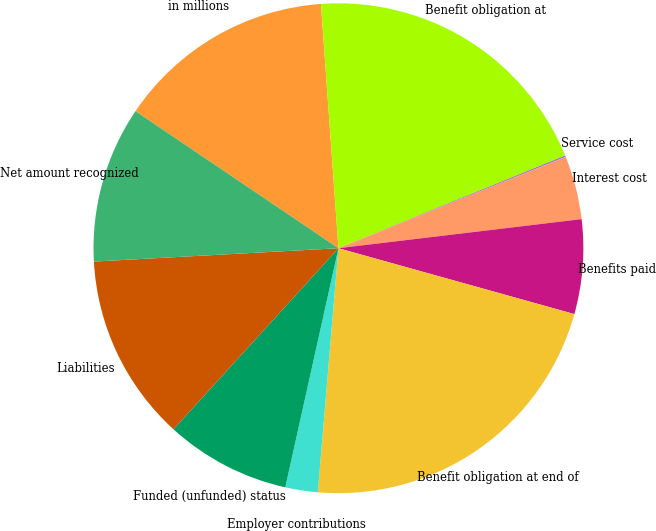Convert chart. <chart><loc_0><loc_0><loc_500><loc_500><pie_chart><fcel>in millions<fcel>Benefit obligation at<fcel>Service cost<fcel>Interest cost<fcel>Benefits paid<fcel>Benefit obligation at end of<fcel>Employer contributions<fcel>Funded (unfunded) status<fcel>Liabilities<fcel>Net amount recognized<nl><fcel>14.41%<fcel>19.96%<fcel>0.09%<fcel>4.19%<fcel>6.23%<fcel>22.01%<fcel>2.14%<fcel>8.28%<fcel>12.37%<fcel>10.32%<nl></chart> 